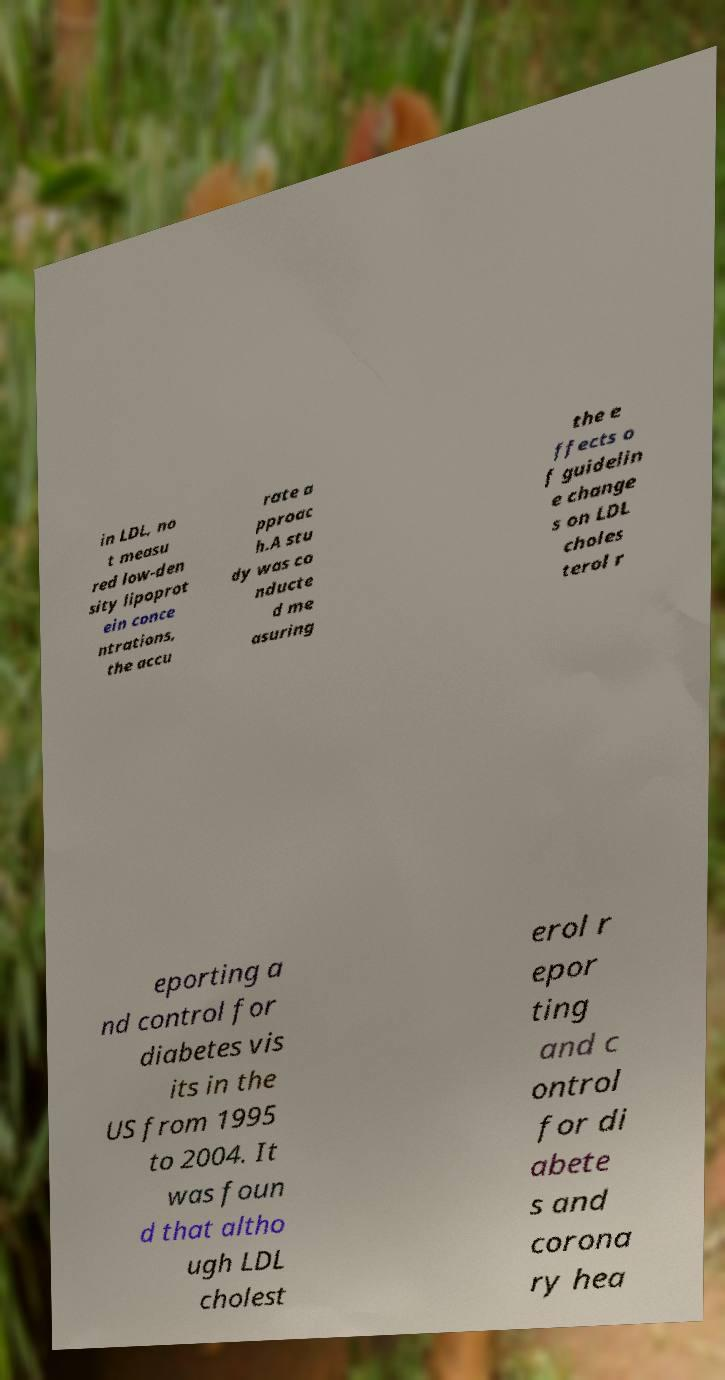There's text embedded in this image that I need extracted. Can you transcribe it verbatim? in LDL, no t measu red low-den sity lipoprot ein conce ntrations, the accu rate a pproac h.A stu dy was co nducte d me asuring the e ffects o f guidelin e change s on LDL choles terol r eporting a nd control for diabetes vis its in the US from 1995 to 2004. It was foun d that altho ugh LDL cholest erol r epor ting and c ontrol for di abete s and corona ry hea 